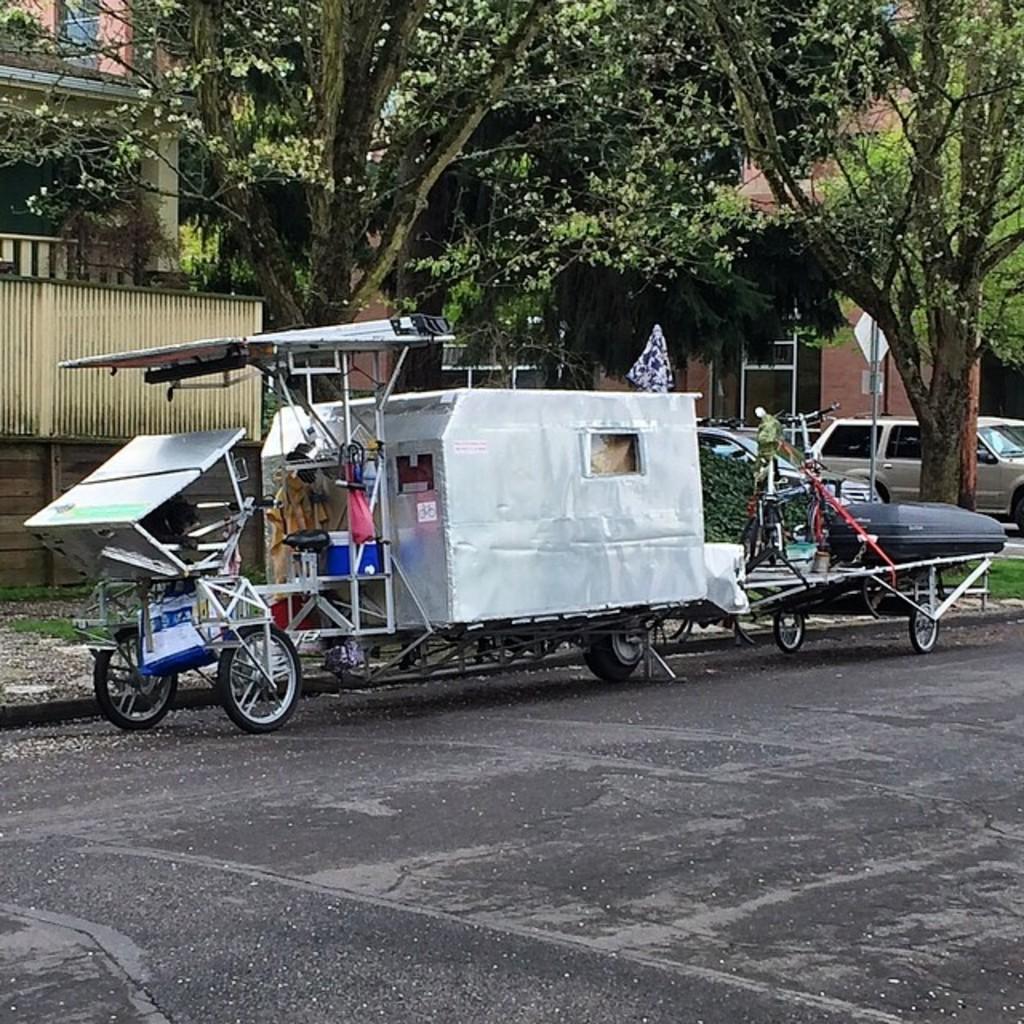How would you summarize this image in a sentence or two? In this picture we can see few vehicles on the road, in the background we can find few trees, buildings and sign boards, on the left side of the image we can see fence. 